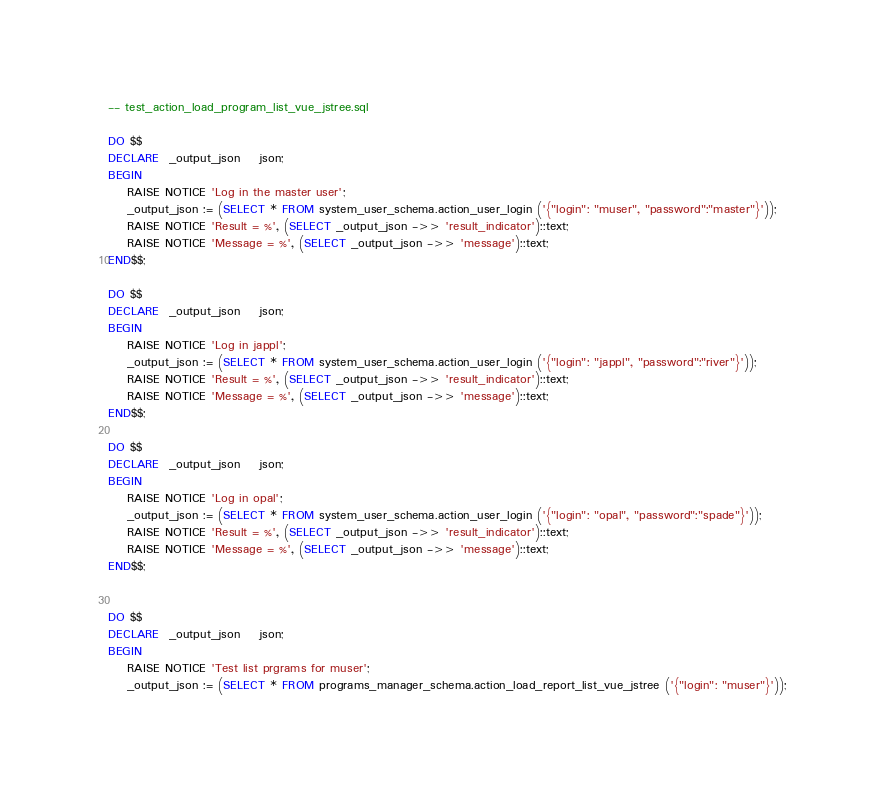<code> <loc_0><loc_0><loc_500><loc_500><_SQL_>-- test_action_load_program_list_vue_jstree.sql

DO $$
DECLARE  _output_json	json;
BEGIN	
	RAISE NOTICE 'Log in the master user';
	_output_json := (SELECT * FROM system_user_schema.action_user_login ('{"login": "muser", "password":"master"}'));
	RAISE NOTICE 'Result = %', (SELECT _output_json ->> 'result_indicator')::text;
	RAISE NOTICE 'Message = %', (SELECT _output_json ->> 'message')::text;
END$$;

DO $$
DECLARE  _output_json	json;
BEGIN	
	RAISE NOTICE 'Log in jappl';
	_output_json := (SELECT * FROM system_user_schema.action_user_login ('{"login": "jappl", "password":"river"}'));
	RAISE NOTICE 'Result = %', (SELECT _output_json ->> 'result_indicator')::text;
	RAISE NOTICE 'Message = %', (SELECT _output_json ->> 'message')::text;
END$$;

DO $$
DECLARE  _output_json	json;
BEGIN	
	RAISE NOTICE 'Log in opal';
	_output_json := (SELECT * FROM system_user_schema.action_user_login ('{"login": "opal", "password":"spade"}'));
	RAISE NOTICE 'Result = %', (SELECT _output_json ->> 'result_indicator')::text;
	RAISE NOTICE 'Message = %', (SELECT _output_json ->> 'message')::text;
END$$;


DO $$
DECLARE  _output_json	json;
BEGIN	
	RAISE NOTICE 'Test list prgrams for muser';
	_output_json := (SELECT * FROM programs_manager_schema.action_load_report_list_vue_jstree ('{"login": "muser"}'));</code> 